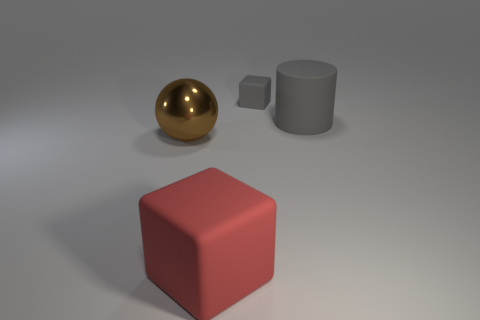Add 1 large blocks. How many objects exist? 5 Subtract 1 blocks. How many blocks are left? 1 Subtract all red cubes. How many cubes are left? 1 Subtract all spheres. How many objects are left? 3 Subtract all large metal balls. Subtract all large balls. How many objects are left? 2 Add 1 big red things. How many big red things are left? 2 Add 1 small gray metallic balls. How many small gray metallic balls exist? 1 Subtract 0 yellow balls. How many objects are left? 4 Subtract all red balls. Subtract all yellow cubes. How many balls are left? 1 Subtract all red cylinders. How many red blocks are left? 1 